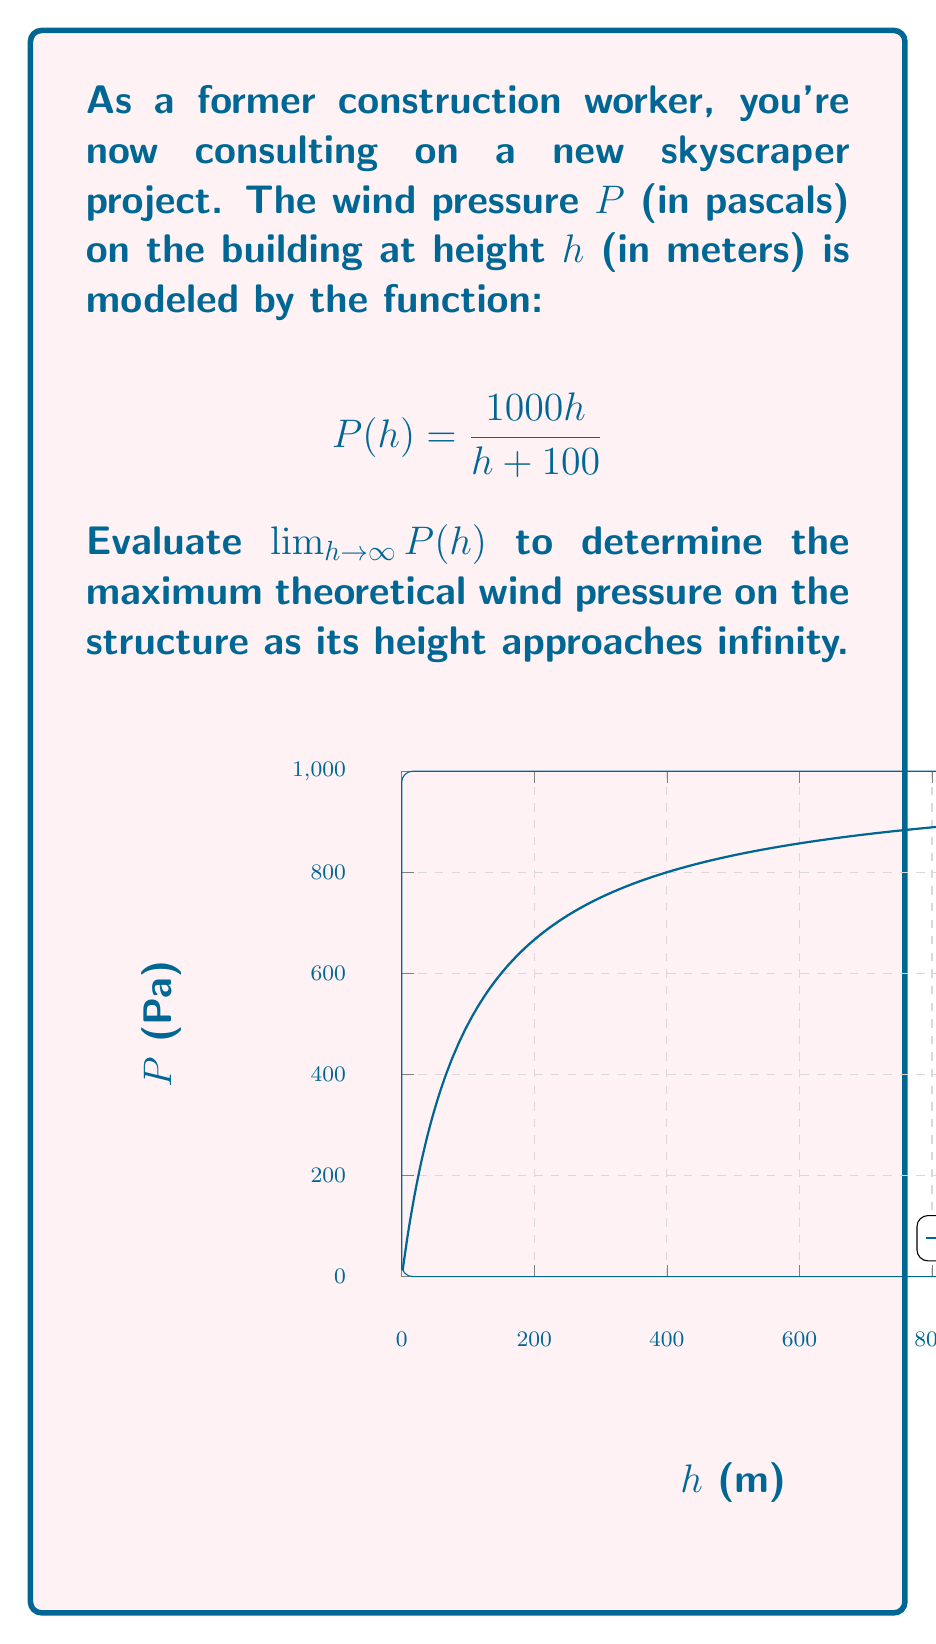What is the answer to this math problem? To evaluate this limit, we'll follow these steps:

1) First, let's examine the function:
   $$P(h) = \frac{1000h}{h + 100}$$

2) As $h$ approaches infinity, both the numerator and denominator grow without bound. This is an indeterminate form of type $\frac{\infty}{\infty}$.

3) To resolve this, we can divide both the numerator and denominator by $h$:

   $$\lim_{h \to \infty} P(h) = \lim_{h \to \infty} \frac{1000h}{h + 100} = \lim_{h \to \infty} \frac{1000h/h}{h/h + 100/h}$$

4) Simplify:
   $$= \lim_{h \to \infty} \frac{1000}{1 + 100/h}$$

5) As $h$ approaches infinity, $100/h$ approaches 0:
   $$= \frac{1000}{1 + 0} = 1000$$

Therefore, as the height approaches infinity, the wind pressure approaches 1000 pascals.
Answer: $1000$ Pa 